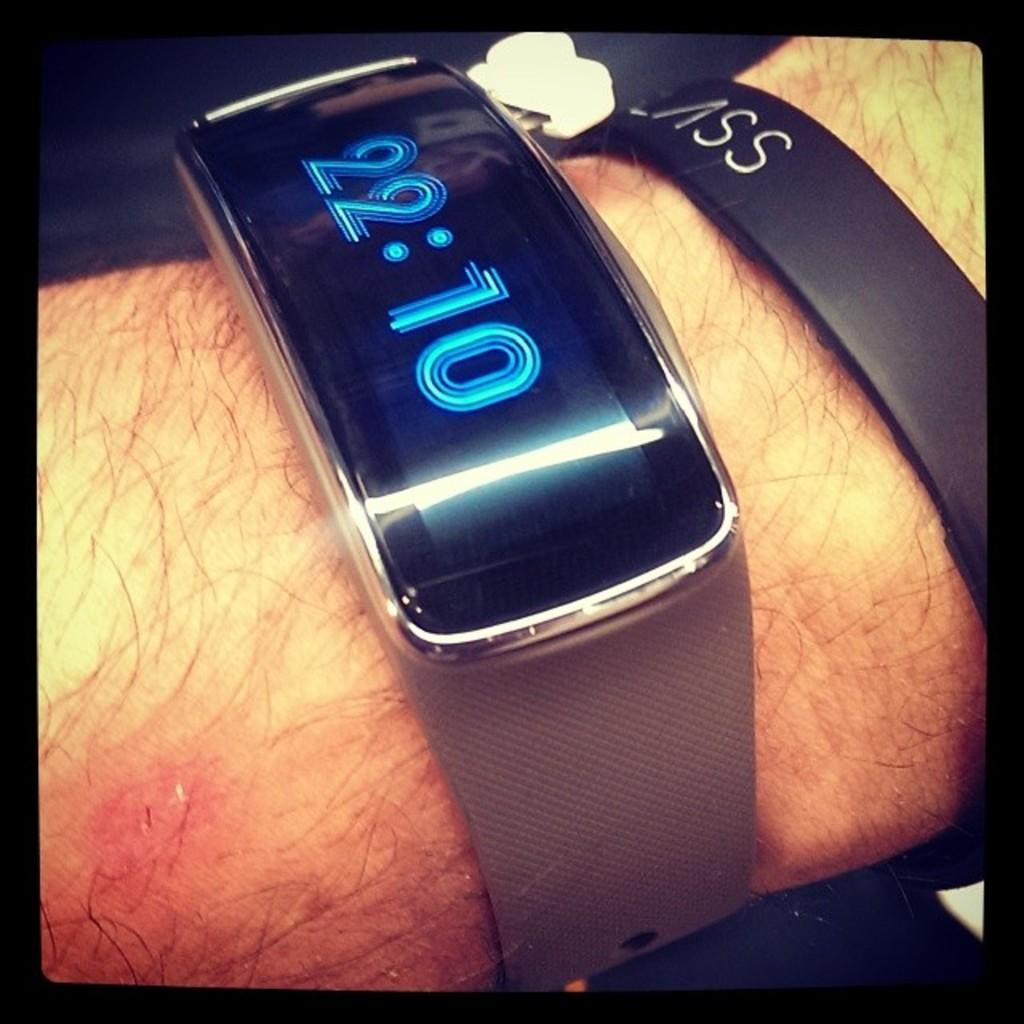<image>
Provide a brief description of the given image. A person is wearing a digital watch that displays a time of 22:10. 